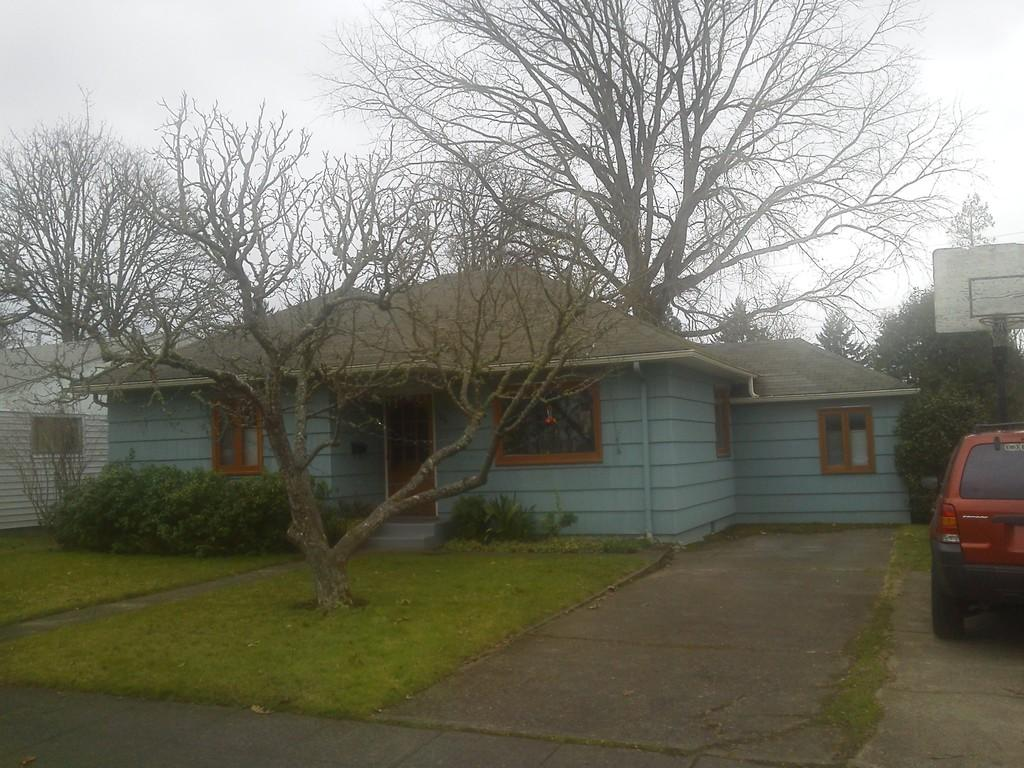What type of vegetation can be seen in the image? There is grass in the image. What type of vehicle is present in the image? There is a car in the image. What other natural elements can be seen in the image? There are trees in the image. What type of structures are visible in the image? There are houses in the image. What is visible in the background of the image? The sky is visible in the background of the image. When was the image taken? The image was taken during the day. What day of the week is depicted in the image? The image does not depict a specific day of the week; it only shows the time of day (daytime). Can you see any animals biting the trees in the image? There are no animals visible in the image, let alone any biting the trees. 